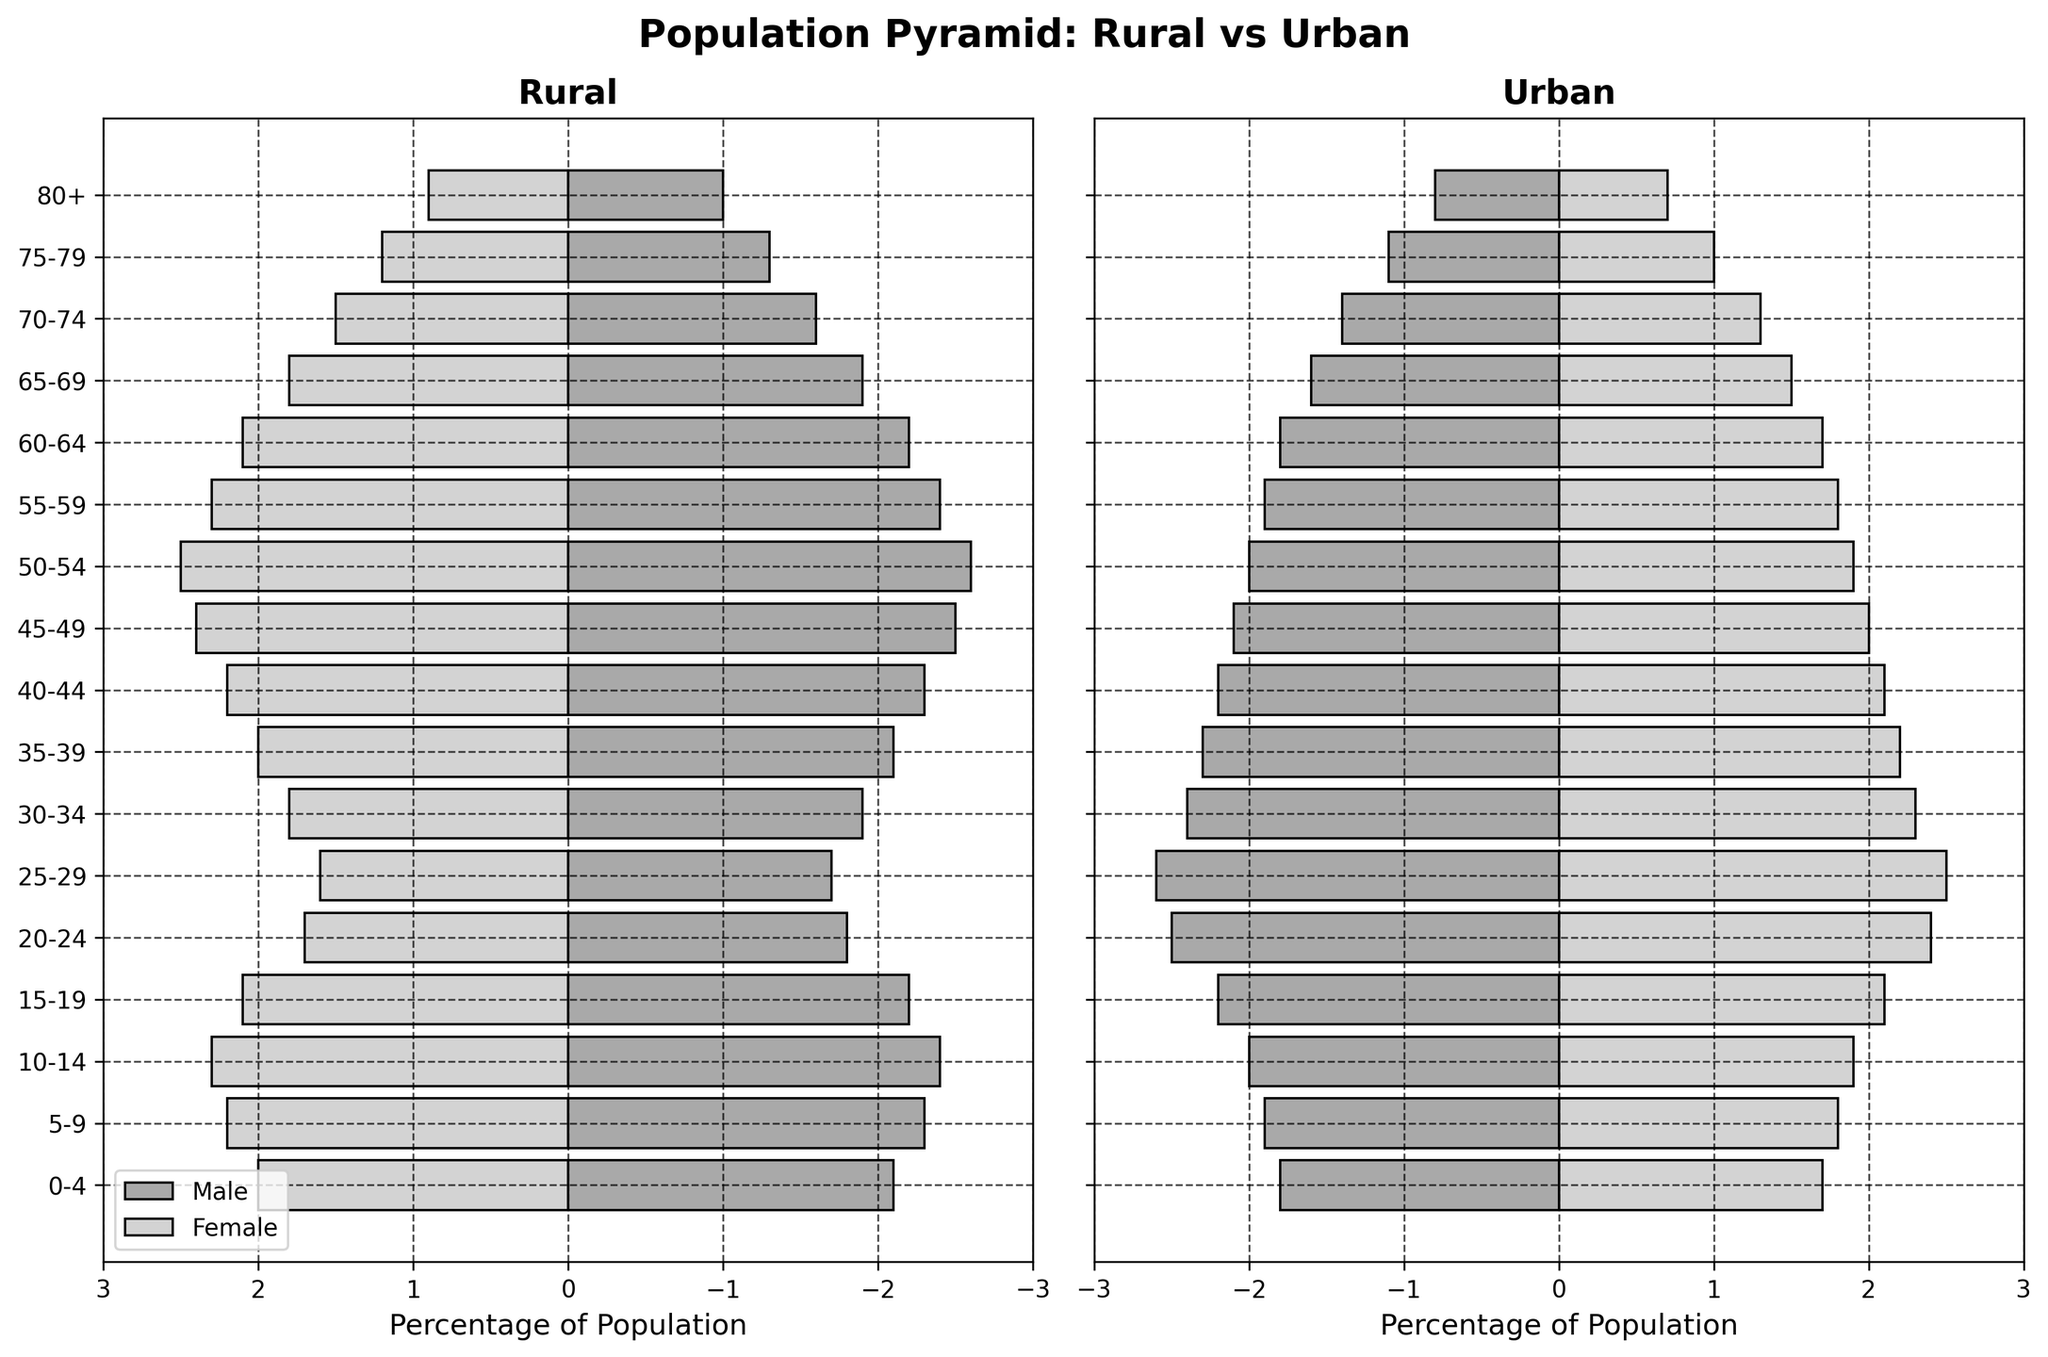What is the title of the population pyramid figure? The title is clearly displayed at the top of the figure, reading "Population Pyramid: Rural vs Urban".
Answer: Population Pyramid: Rural vs Urban Which age group has the highest percentage in the rural male population? By observing the lengths of the bars on the rural male side, the age group 50-54 has the longest bar, indicating the highest percentage.
Answer: 50-54 In the age group 25-29, which area has a higher male population percentage, rural or urban? For the age group 25-29, the urban male bar is longer (-2.6) compared to the rural male bar (-1.7), indicating a higher male population percentage in urban areas.
Answer: Urban What is the combined percentage of rural females and urban females in the age group 20-24? The percentage for rural females is 1.7, and for urban females, it is 2.4 in the age group 20-24. Adding these together gives 1.7 + 2.4 = 4.1.
Answer: 4.1 How does the percentage of population in the age group 70-74 compare between rural males and urban males? The bar for rural males in the age group 70-74 is -1.6, while the bar for urban males is -1.4. Rural males have a higher percentage than urban males.
Answer: Rural males have a higher percentage In which age group is the difference in percentage between rural females and urban females the smallest? By comparing the bars for each age group, we see that in the age group 15-19, the difference between rural females (2.1) and urban females (2.1) is 0, which is the smallest difference.
Answer: 15-19 What trend can be observed in urban female population percentages as the age groups increase? Observing the bars for urban females, we notice a general decreasing trend in population percentage as age groups increase, with a few fluctuations.
Answer: Decreasing trend Which population (rural or urban) and gender has the highest percentage in the age group 80+? In the age group 80+, the rural female bar is 0.9%, the highest among the listed populations and genders.
Answer: Rural Female In the age group 35-39, is the percentage of urban males greater or less than that of rural males? For the age group 35-39, the urban male percentage is -2.3, whereas the rural male percentage is -2.1. The percentage is greater for rural males.
Answer: Rural males In which age group are both rural and urban male percentages equal? By examining the bars for each age group, we find that in the age group 15-19, both rural and urban male percentages are -2.2, showing they are equal.
Answer: 15-19 